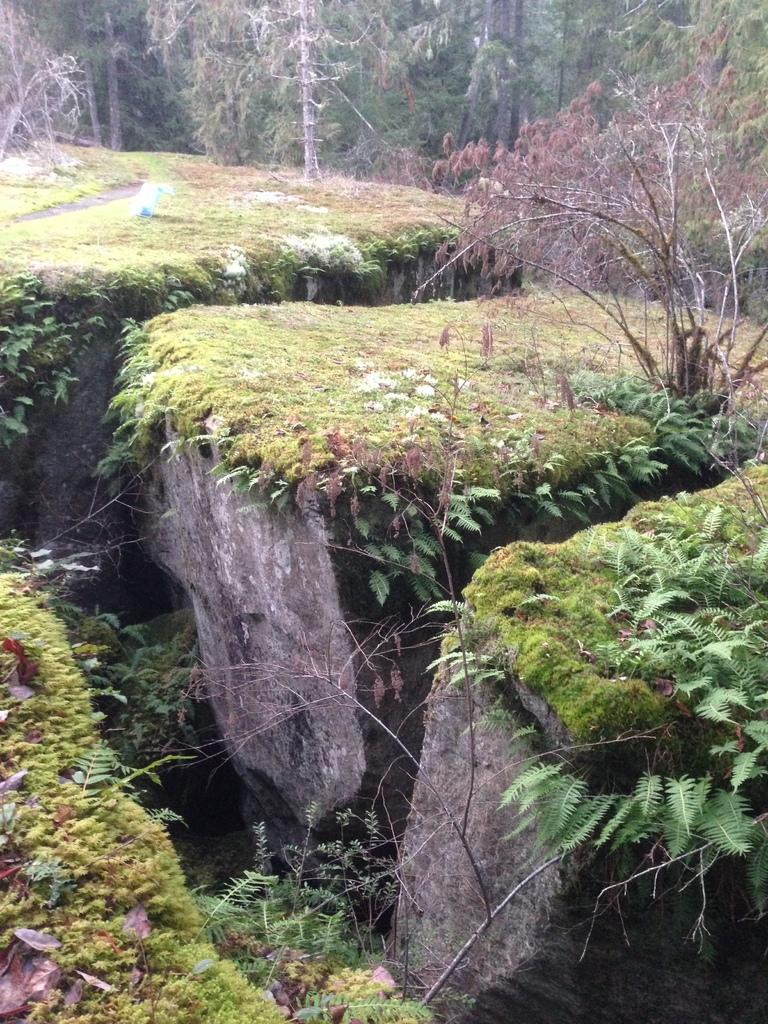What type of natural elements can be seen in the image? There are large stones in the image. What is growing on the stones? There is grass and plants on the stones. What can be seen in the background of the image? There are trees in the background of the image. What type of force is being applied to the stones in the image? There is no indication of any force being applied to the stones in the image. What kind of wax can be seen dripping from the plants in the image? There is no wax present in the image; it features stones, grass, plants, and trees. 